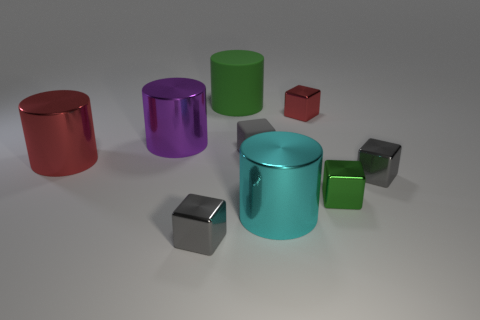There is a tiny block that is the same color as the big matte object; what material is it?
Ensure brevity in your answer.  Metal. Is the material of the small red block the same as the large cyan object?
Offer a very short reply. Yes. How many other small objects have the same material as the cyan object?
Keep it short and to the point. 4. What is the color of the tiny block that is the same material as the big green cylinder?
Make the answer very short. Gray. What is the shape of the big cyan thing?
Your response must be concise. Cylinder. There is a small gray cube behind the red metal cylinder; what material is it?
Your response must be concise. Rubber. Are there any things of the same color as the tiny matte cube?
Your answer should be very brief. Yes. The red metallic object that is the same size as the purple metal cylinder is what shape?
Provide a short and direct response. Cylinder. What color is the big metallic cylinder that is in front of the red shiny cylinder?
Provide a succinct answer. Cyan. Are there any purple objects that are in front of the cube to the right of the green shiny block?
Your response must be concise. No. 